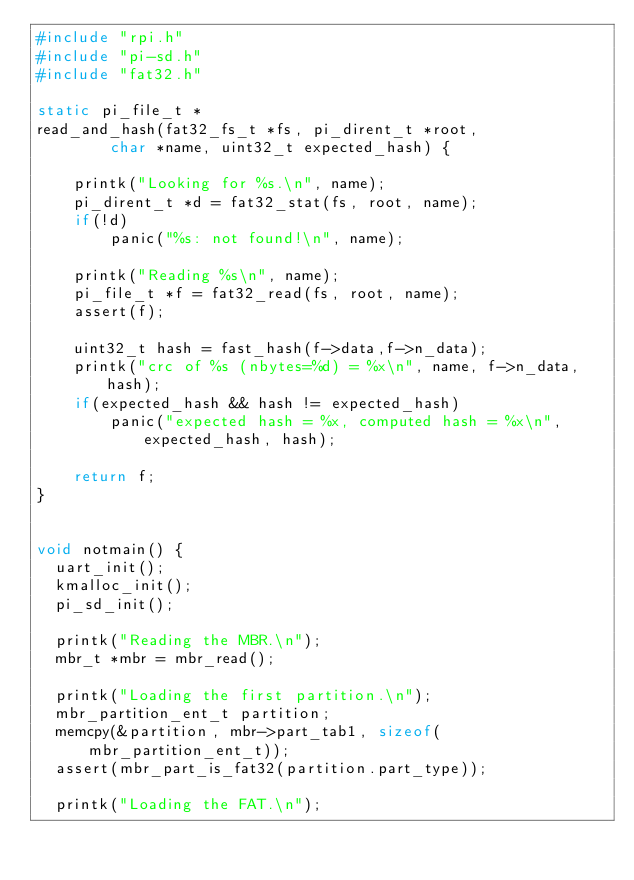Convert code to text. <code><loc_0><loc_0><loc_500><loc_500><_C_>#include "rpi.h"
#include "pi-sd.h"
#include "fat32.h"

static pi_file_t *
read_and_hash(fat32_fs_t *fs, pi_dirent_t *root, 
        char *name, uint32_t expected_hash) {

    printk("Looking for %s.\n", name);
    pi_dirent_t *d = fat32_stat(fs, root, name);
    if(!d)
        panic("%s: not found!\n", name);

    printk("Reading %s\n", name);
    pi_file_t *f = fat32_read(fs, root, name);
    assert(f);

    uint32_t hash = fast_hash(f->data,f->n_data);
    printk("crc of %s (nbytes=%d) = %x\n", name, f->n_data, hash);
    if(expected_hash && hash != expected_hash)
        panic("expected hash = %x, computed hash = %x\n", expected_hash, hash);

    return f;
}


void notmain() {
  uart_init();
  kmalloc_init();
  pi_sd_init();

  printk("Reading the MBR.\n");
  mbr_t *mbr = mbr_read();

  printk("Loading the first partition.\n");
  mbr_partition_ent_t partition;
  memcpy(&partition, mbr->part_tab1, sizeof(mbr_partition_ent_t));
  assert(mbr_part_is_fat32(partition.part_type));

  printk("Loading the FAT.\n");</code> 